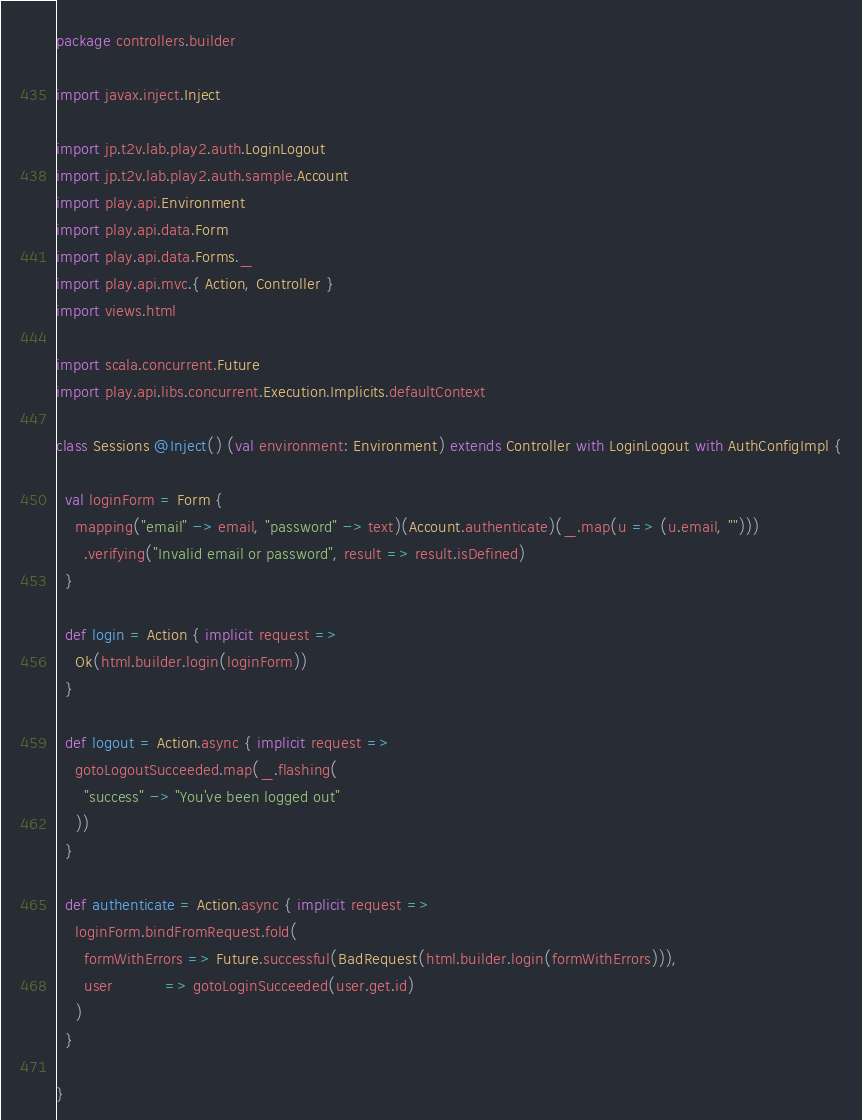Convert code to text. <code><loc_0><loc_0><loc_500><loc_500><_Scala_>package controllers.builder

import javax.inject.Inject

import jp.t2v.lab.play2.auth.LoginLogout
import jp.t2v.lab.play2.auth.sample.Account
import play.api.Environment
import play.api.data.Form
import play.api.data.Forms._
import play.api.mvc.{ Action, Controller }
import views.html

import scala.concurrent.Future
import play.api.libs.concurrent.Execution.Implicits.defaultContext

class Sessions @Inject() (val environment: Environment) extends Controller with LoginLogout with AuthConfigImpl {

  val loginForm = Form {
    mapping("email" -> email, "password" -> text)(Account.authenticate)(_.map(u => (u.email, "")))
      .verifying("Invalid email or password", result => result.isDefined)
  }

  def login = Action { implicit request =>
    Ok(html.builder.login(loginForm))
  }

  def logout = Action.async { implicit request =>
    gotoLogoutSucceeded.map(_.flashing(
      "success" -> "You've been logged out"
    ))
  }

  def authenticate = Action.async { implicit request =>
    loginForm.bindFromRequest.fold(
      formWithErrors => Future.successful(BadRequest(html.builder.login(formWithErrors))),
      user           => gotoLoginSucceeded(user.get.id)
    )
  }

}</code> 